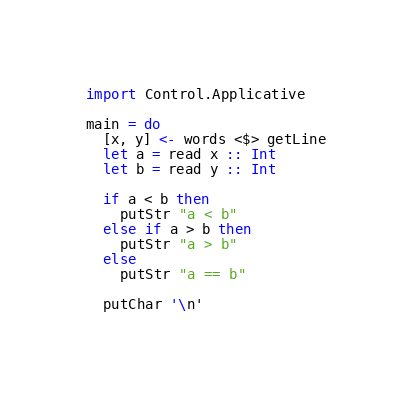Convert code to text. <code><loc_0><loc_0><loc_500><loc_500><_Haskell_>import Control.Applicative

main = do
  [x, y] <- words <$> getLine
  let a = read x :: Int
  let b = read y :: Int

  if a < b then
    putStr "a < b"
  else if a > b then
    putStr "a > b"
  else
    putStr "a == b"

  putChar '\n'</code> 